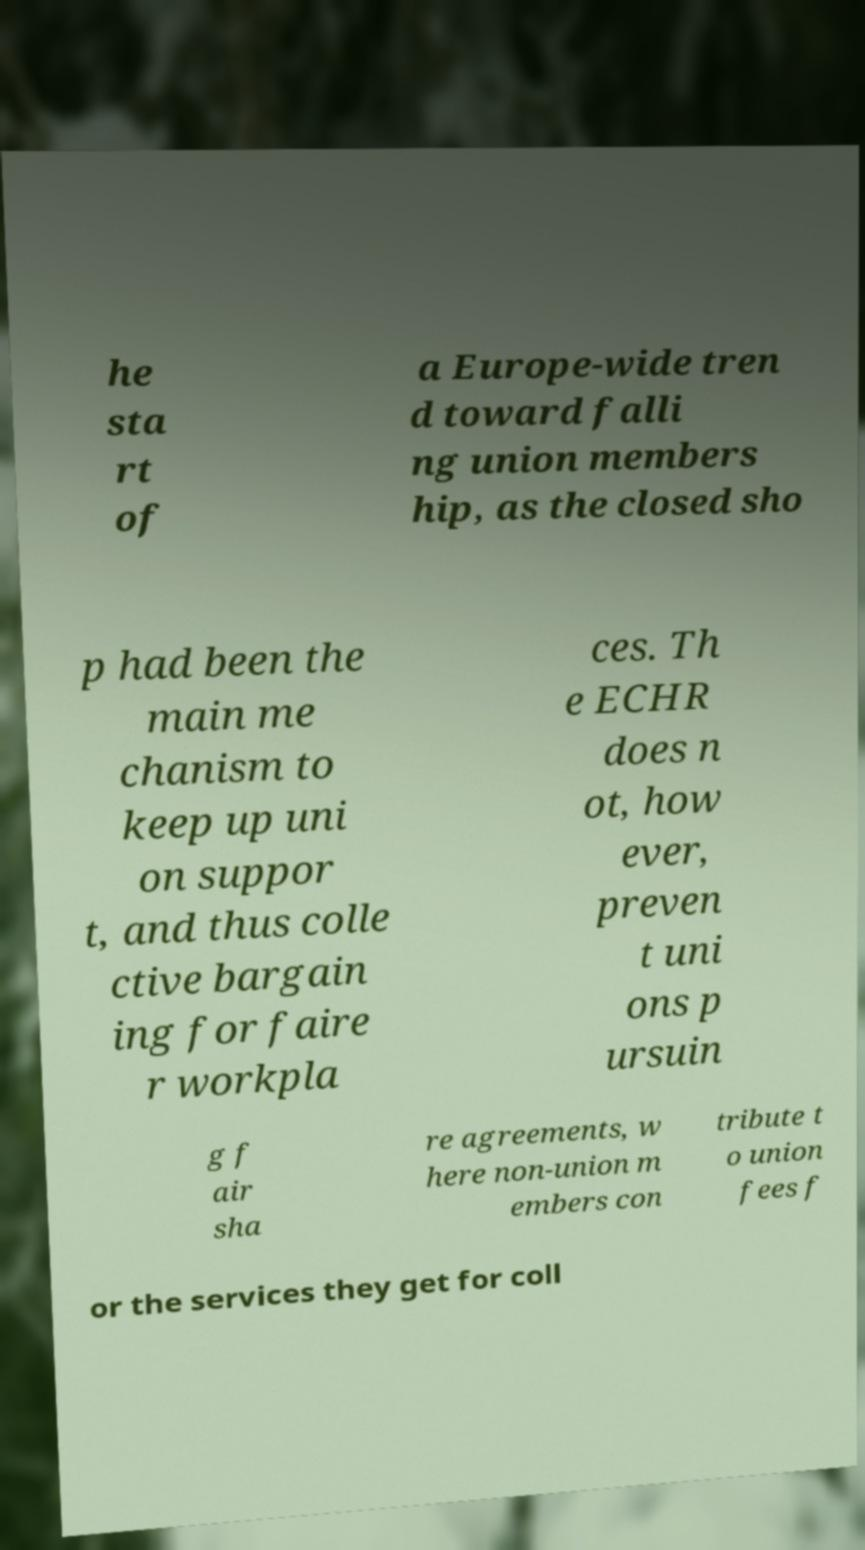Please identify and transcribe the text found in this image. he sta rt of a Europe-wide tren d toward falli ng union members hip, as the closed sho p had been the main me chanism to keep up uni on suppor t, and thus colle ctive bargain ing for faire r workpla ces. Th e ECHR does n ot, how ever, preven t uni ons p ursuin g f air sha re agreements, w here non-union m embers con tribute t o union fees f or the services they get for coll 